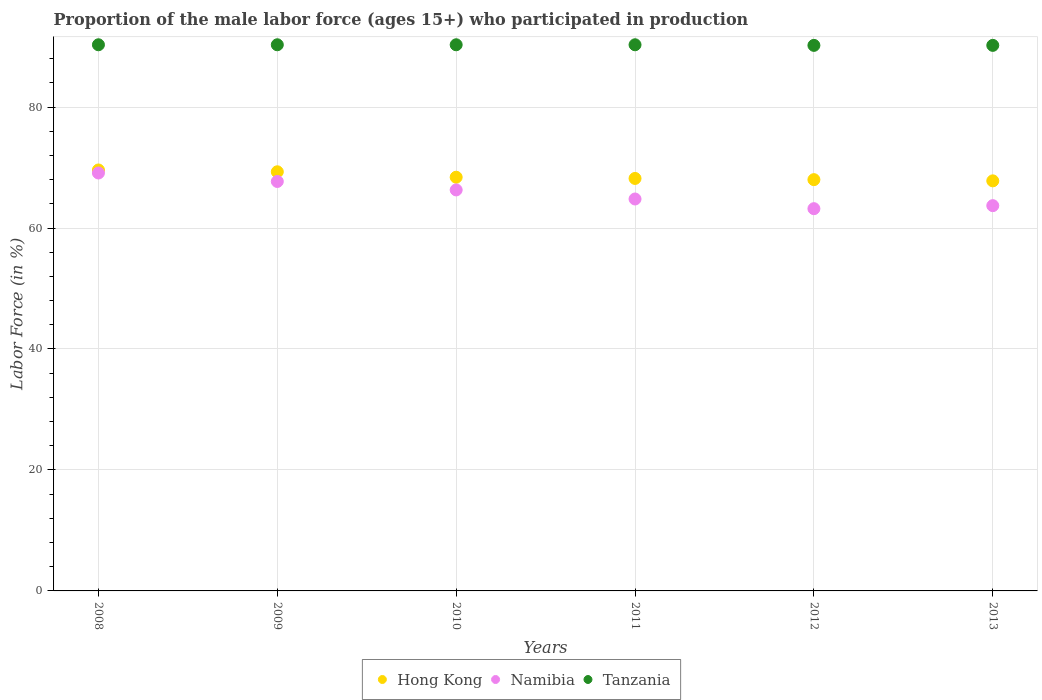How many different coloured dotlines are there?
Your response must be concise. 3. What is the proportion of the male labor force who participated in production in Namibia in 2008?
Make the answer very short. 69.1. Across all years, what is the maximum proportion of the male labor force who participated in production in Tanzania?
Give a very brief answer. 90.3. Across all years, what is the minimum proportion of the male labor force who participated in production in Namibia?
Provide a short and direct response. 63.2. In which year was the proportion of the male labor force who participated in production in Tanzania minimum?
Make the answer very short. 2012. What is the total proportion of the male labor force who participated in production in Tanzania in the graph?
Give a very brief answer. 541.6. What is the difference between the proportion of the male labor force who participated in production in Namibia in 2010 and that in 2012?
Provide a succinct answer. 3.1. What is the difference between the proportion of the male labor force who participated in production in Namibia in 2013 and the proportion of the male labor force who participated in production in Tanzania in 2010?
Your answer should be compact. -26.6. What is the average proportion of the male labor force who participated in production in Hong Kong per year?
Offer a very short reply. 68.55. In the year 2012, what is the difference between the proportion of the male labor force who participated in production in Namibia and proportion of the male labor force who participated in production in Hong Kong?
Offer a very short reply. -4.8. What is the ratio of the proportion of the male labor force who participated in production in Namibia in 2008 to that in 2009?
Keep it short and to the point. 1.02. Is the proportion of the male labor force who participated in production in Tanzania in 2011 less than that in 2012?
Your response must be concise. No. What is the difference between the highest and the second highest proportion of the male labor force who participated in production in Namibia?
Your answer should be compact. 1.4. What is the difference between the highest and the lowest proportion of the male labor force who participated in production in Hong Kong?
Your response must be concise. 1.8. Is the sum of the proportion of the male labor force who participated in production in Namibia in 2009 and 2012 greater than the maximum proportion of the male labor force who participated in production in Hong Kong across all years?
Make the answer very short. Yes. Does the proportion of the male labor force who participated in production in Namibia monotonically increase over the years?
Your response must be concise. No. Are the values on the major ticks of Y-axis written in scientific E-notation?
Your answer should be very brief. No. Does the graph contain grids?
Offer a terse response. Yes. Where does the legend appear in the graph?
Offer a very short reply. Bottom center. How many legend labels are there?
Provide a succinct answer. 3. What is the title of the graph?
Keep it short and to the point. Proportion of the male labor force (ages 15+) who participated in production. What is the label or title of the X-axis?
Your response must be concise. Years. What is the Labor Force (in %) of Hong Kong in 2008?
Offer a very short reply. 69.6. What is the Labor Force (in %) in Namibia in 2008?
Ensure brevity in your answer.  69.1. What is the Labor Force (in %) of Tanzania in 2008?
Your answer should be very brief. 90.3. What is the Labor Force (in %) of Hong Kong in 2009?
Make the answer very short. 69.3. What is the Labor Force (in %) of Namibia in 2009?
Your response must be concise. 67.7. What is the Labor Force (in %) in Tanzania in 2009?
Ensure brevity in your answer.  90.3. What is the Labor Force (in %) in Hong Kong in 2010?
Provide a short and direct response. 68.4. What is the Labor Force (in %) in Namibia in 2010?
Your answer should be very brief. 66.3. What is the Labor Force (in %) of Tanzania in 2010?
Offer a terse response. 90.3. What is the Labor Force (in %) in Hong Kong in 2011?
Keep it short and to the point. 68.2. What is the Labor Force (in %) of Namibia in 2011?
Ensure brevity in your answer.  64.8. What is the Labor Force (in %) of Tanzania in 2011?
Your answer should be compact. 90.3. What is the Labor Force (in %) of Hong Kong in 2012?
Make the answer very short. 68. What is the Labor Force (in %) of Namibia in 2012?
Make the answer very short. 63.2. What is the Labor Force (in %) of Tanzania in 2012?
Offer a very short reply. 90.2. What is the Labor Force (in %) of Hong Kong in 2013?
Provide a short and direct response. 67.8. What is the Labor Force (in %) of Namibia in 2013?
Provide a short and direct response. 63.7. What is the Labor Force (in %) in Tanzania in 2013?
Offer a very short reply. 90.2. Across all years, what is the maximum Labor Force (in %) in Hong Kong?
Offer a terse response. 69.6. Across all years, what is the maximum Labor Force (in %) of Namibia?
Ensure brevity in your answer.  69.1. Across all years, what is the maximum Labor Force (in %) in Tanzania?
Provide a short and direct response. 90.3. Across all years, what is the minimum Labor Force (in %) in Hong Kong?
Your response must be concise. 67.8. Across all years, what is the minimum Labor Force (in %) in Namibia?
Your answer should be very brief. 63.2. Across all years, what is the minimum Labor Force (in %) of Tanzania?
Provide a short and direct response. 90.2. What is the total Labor Force (in %) in Hong Kong in the graph?
Offer a very short reply. 411.3. What is the total Labor Force (in %) of Namibia in the graph?
Provide a short and direct response. 394.8. What is the total Labor Force (in %) in Tanzania in the graph?
Your answer should be very brief. 541.6. What is the difference between the Labor Force (in %) in Hong Kong in 2008 and that in 2009?
Your response must be concise. 0.3. What is the difference between the Labor Force (in %) of Namibia in 2008 and that in 2010?
Give a very brief answer. 2.8. What is the difference between the Labor Force (in %) of Hong Kong in 2008 and that in 2011?
Make the answer very short. 1.4. What is the difference between the Labor Force (in %) of Tanzania in 2008 and that in 2011?
Your answer should be compact. 0. What is the difference between the Labor Force (in %) in Namibia in 2008 and that in 2012?
Offer a very short reply. 5.9. What is the difference between the Labor Force (in %) of Hong Kong in 2008 and that in 2013?
Ensure brevity in your answer.  1.8. What is the difference between the Labor Force (in %) in Hong Kong in 2009 and that in 2010?
Offer a terse response. 0.9. What is the difference between the Labor Force (in %) of Tanzania in 2009 and that in 2010?
Your answer should be very brief. 0. What is the difference between the Labor Force (in %) of Hong Kong in 2009 and that in 2011?
Ensure brevity in your answer.  1.1. What is the difference between the Labor Force (in %) of Namibia in 2009 and that in 2011?
Offer a very short reply. 2.9. What is the difference between the Labor Force (in %) of Hong Kong in 2009 and that in 2012?
Give a very brief answer. 1.3. What is the difference between the Labor Force (in %) in Tanzania in 2009 and that in 2012?
Provide a short and direct response. 0.1. What is the difference between the Labor Force (in %) in Hong Kong in 2009 and that in 2013?
Make the answer very short. 1.5. What is the difference between the Labor Force (in %) of Namibia in 2009 and that in 2013?
Your response must be concise. 4. What is the difference between the Labor Force (in %) in Tanzania in 2009 and that in 2013?
Provide a succinct answer. 0.1. What is the difference between the Labor Force (in %) of Hong Kong in 2010 and that in 2011?
Offer a very short reply. 0.2. What is the difference between the Labor Force (in %) of Hong Kong in 2010 and that in 2012?
Give a very brief answer. 0.4. What is the difference between the Labor Force (in %) of Namibia in 2010 and that in 2012?
Your answer should be very brief. 3.1. What is the difference between the Labor Force (in %) in Namibia in 2011 and that in 2012?
Make the answer very short. 1.6. What is the difference between the Labor Force (in %) of Namibia in 2011 and that in 2013?
Give a very brief answer. 1.1. What is the difference between the Labor Force (in %) in Hong Kong in 2012 and that in 2013?
Make the answer very short. 0.2. What is the difference between the Labor Force (in %) in Tanzania in 2012 and that in 2013?
Make the answer very short. 0. What is the difference between the Labor Force (in %) of Hong Kong in 2008 and the Labor Force (in %) of Tanzania in 2009?
Your answer should be compact. -20.7. What is the difference between the Labor Force (in %) in Namibia in 2008 and the Labor Force (in %) in Tanzania in 2009?
Offer a very short reply. -21.2. What is the difference between the Labor Force (in %) of Hong Kong in 2008 and the Labor Force (in %) of Namibia in 2010?
Give a very brief answer. 3.3. What is the difference between the Labor Force (in %) of Hong Kong in 2008 and the Labor Force (in %) of Tanzania in 2010?
Offer a very short reply. -20.7. What is the difference between the Labor Force (in %) in Namibia in 2008 and the Labor Force (in %) in Tanzania in 2010?
Give a very brief answer. -21.2. What is the difference between the Labor Force (in %) of Hong Kong in 2008 and the Labor Force (in %) of Tanzania in 2011?
Give a very brief answer. -20.7. What is the difference between the Labor Force (in %) of Namibia in 2008 and the Labor Force (in %) of Tanzania in 2011?
Your response must be concise. -21.2. What is the difference between the Labor Force (in %) of Hong Kong in 2008 and the Labor Force (in %) of Tanzania in 2012?
Your answer should be very brief. -20.6. What is the difference between the Labor Force (in %) in Namibia in 2008 and the Labor Force (in %) in Tanzania in 2012?
Give a very brief answer. -21.1. What is the difference between the Labor Force (in %) of Hong Kong in 2008 and the Labor Force (in %) of Namibia in 2013?
Your response must be concise. 5.9. What is the difference between the Labor Force (in %) in Hong Kong in 2008 and the Labor Force (in %) in Tanzania in 2013?
Provide a short and direct response. -20.6. What is the difference between the Labor Force (in %) of Namibia in 2008 and the Labor Force (in %) of Tanzania in 2013?
Keep it short and to the point. -21.1. What is the difference between the Labor Force (in %) in Hong Kong in 2009 and the Labor Force (in %) in Namibia in 2010?
Give a very brief answer. 3. What is the difference between the Labor Force (in %) of Namibia in 2009 and the Labor Force (in %) of Tanzania in 2010?
Your response must be concise. -22.6. What is the difference between the Labor Force (in %) in Namibia in 2009 and the Labor Force (in %) in Tanzania in 2011?
Offer a very short reply. -22.6. What is the difference between the Labor Force (in %) in Hong Kong in 2009 and the Labor Force (in %) in Namibia in 2012?
Provide a short and direct response. 6.1. What is the difference between the Labor Force (in %) of Hong Kong in 2009 and the Labor Force (in %) of Tanzania in 2012?
Give a very brief answer. -20.9. What is the difference between the Labor Force (in %) in Namibia in 2009 and the Labor Force (in %) in Tanzania in 2012?
Provide a succinct answer. -22.5. What is the difference between the Labor Force (in %) of Hong Kong in 2009 and the Labor Force (in %) of Namibia in 2013?
Provide a succinct answer. 5.6. What is the difference between the Labor Force (in %) of Hong Kong in 2009 and the Labor Force (in %) of Tanzania in 2013?
Provide a succinct answer. -20.9. What is the difference between the Labor Force (in %) in Namibia in 2009 and the Labor Force (in %) in Tanzania in 2013?
Keep it short and to the point. -22.5. What is the difference between the Labor Force (in %) of Hong Kong in 2010 and the Labor Force (in %) of Tanzania in 2011?
Offer a very short reply. -21.9. What is the difference between the Labor Force (in %) in Namibia in 2010 and the Labor Force (in %) in Tanzania in 2011?
Provide a succinct answer. -24. What is the difference between the Labor Force (in %) in Hong Kong in 2010 and the Labor Force (in %) in Namibia in 2012?
Your answer should be very brief. 5.2. What is the difference between the Labor Force (in %) in Hong Kong in 2010 and the Labor Force (in %) in Tanzania in 2012?
Make the answer very short. -21.8. What is the difference between the Labor Force (in %) of Namibia in 2010 and the Labor Force (in %) of Tanzania in 2012?
Offer a terse response. -23.9. What is the difference between the Labor Force (in %) in Hong Kong in 2010 and the Labor Force (in %) in Namibia in 2013?
Make the answer very short. 4.7. What is the difference between the Labor Force (in %) of Hong Kong in 2010 and the Labor Force (in %) of Tanzania in 2013?
Keep it short and to the point. -21.8. What is the difference between the Labor Force (in %) of Namibia in 2010 and the Labor Force (in %) of Tanzania in 2013?
Provide a short and direct response. -23.9. What is the difference between the Labor Force (in %) in Namibia in 2011 and the Labor Force (in %) in Tanzania in 2012?
Ensure brevity in your answer.  -25.4. What is the difference between the Labor Force (in %) in Namibia in 2011 and the Labor Force (in %) in Tanzania in 2013?
Provide a short and direct response. -25.4. What is the difference between the Labor Force (in %) of Hong Kong in 2012 and the Labor Force (in %) of Namibia in 2013?
Your response must be concise. 4.3. What is the difference between the Labor Force (in %) in Hong Kong in 2012 and the Labor Force (in %) in Tanzania in 2013?
Make the answer very short. -22.2. What is the difference between the Labor Force (in %) of Namibia in 2012 and the Labor Force (in %) of Tanzania in 2013?
Give a very brief answer. -27. What is the average Labor Force (in %) in Hong Kong per year?
Provide a succinct answer. 68.55. What is the average Labor Force (in %) of Namibia per year?
Keep it short and to the point. 65.8. What is the average Labor Force (in %) of Tanzania per year?
Your response must be concise. 90.27. In the year 2008, what is the difference between the Labor Force (in %) of Hong Kong and Labor Force (in %) of Tanzania?
Provide a short and direct response. -20.7. In the year 2008, what is the difference between the Labor Force (in %) of Namibia and Labor Force (in %) of Tanzania?
Provide a short and direct response. -21.2. In the year 2009, what is the difference between the Labor Force (in %) in Namibia and Labor Force (in %) in Tanzania?
Your response must be concise. -22.6. In the year 2010, what is the difference between the Labor Force (in %) in Hong Kong and Labor Force (in %) in Namibia?
Your answer should be compact. 2.1. In the year 2010, what is the difference between the Labor Force (in %) in Hong Kong and Labor Force (in %) in Tanzania?
Your answer should be compact. -21.9. In the year 2011, what is the difference between the Labor Force (in %) in Hong Kong and Labor Force (in %) in Tanzania?
Your answer should be very brief. -22.1. In the year 2011, what is the difference between the Labor Force (in %) of Namibia and Labor Force (in %) of Tanzania?
Make the answer very short. -25.5. In the year 2012, what is the difference between the Labor Force (in %) in Hong Kong and Labor Force (in %) in Tanzania?
Provide a succinct answer. -22.2. In the year 2012, what is the difference between the Labor Force (in %) in Namibia and Labor Force (in %) in Tanzania?
Ensure brevity in your answer.  -27. In the year 2013, what is the difference between the Labor Force (in %) of Hong Kong and Labor Force (in %) of Tanzania?
Make the answer very short. -22.4. In the year 2013, what is the difference between the Labor Force (in %) of Namibia and Labor Force (in %) of Tanzania?
Your answer should be very brief. -26.5. What is the ratio of the Labor Force (in %) of Namibia in 2008 to that in 2009?
Keep it short and to the point. 1.02. What is the ratio of the Labor Force (in %) of Hong Kong in 2008 to that in 2010?
Provide a short and direct response. 1.02. What is the ratio of the Labor Force (in %) of Namibia in 2008 to that in 2010?
Provide a succinct answer. 1.04. What is the ratio of the Labor Force (in %) in Hong Kong in 2008 to that in 2011?
Make the answer very short. 1.02. What is the ratio of the Labor Force (in %) of Namibia in 2008 to that in 2011?
Your answer should be very brief. 1.07. What is the ratio of the Labor Force (in %) of Tanzania in 2008 to that in 2011?
Provide a short and direct response. 1. What is the ratio of the Labor Force (in %) of Hong Kong in 2008 to that in 2012?
Your answer should be very brief. 1.02. What is the ratio of the Labor Force (in %) in Namibia in 2008 to that in 2012?
Offer a very short reply. 1.09. What is the ratio of the Labor Force (in %) in Tanzania in 2008 to that in 2012?
Keep it short and to the point. 1. What is the ratio of the Labor Force (in %) of Hong Kong in 2008 to that in 2013?
Keep it short and to the point. 1.03. What is the ratio of the Labor Force (in %) of Namibia in 2008 to that in 2013?
Offer a terse response. 1.08. What is the ratio of the Labor Force (in %) of Tanzania in 2008 to that in 2013?
Provide a succinct answer. 1. What is the ratio of the Labor Force (in %) of Hong Kong in 2009 to that in 2010?
Offer a terse response. 1.01. What is the ratio of the Labor Force (in %) in Namibia in 2009 to that in 2010?
Ensure brevity in your answer.  1.02. What is the ratio of the Labor Force (in %) in Tanzania in 2009 to that in 2010?
Offer a very short reply. 1. What is the ratio of the Labor Force (in %) of Hong Kong in 2009 to that in 2011?
Your answer should be very brief. 1.02. What is the ratio of the Labor Force (in %) in Namibia in 2009 to that in 2011?
Offer a terse response. 1.04. What is the ratio of the Labor Force (in %) of Hong Kong in 2009 to that in 2012?
Ensure brevity in your answer.  1.02. What is the ratio of the Labor Force (in %) of Namibia in 2009 to that in 2012?
Keep it short and to the point. 1.07. What is the ratio of the Labor Force (in %) of Tanzania in 2009 to that in 2012?
Provide a succinct answer. 1. What is the ratio of the Labor Force (in %) of Hong Kong in 2009 to that in 2013?
Your answer should be compact. 1.02. What is the ratio of the Labor Force (in %) in Namibia in 2009 to that in 2013?
Offer a very short reply. 1.06. What is the ratio of the Labor Force (in %) of Hong Kong in 2010 to that in 2011?
Offer a very short reply. 1. What is the ratio of the Labor Force (in %) in Namibia in 2010 to that in 2011?
Offer a terse response. 1.02. What is the ratio of the Labor Force (in %) in Hong Kong in 2010 to that in 2012?
Provide a short and direct response. 1.01. What is the ratio of the Labor Force (in %) in Namibia in 2010 to that in 2012?
Give a very brief answer. 1.05. What is the ratio of the Labor Force (in %) in Hong Kong in 2010 to that in 2013?
Offer a terse response. 1.01. What is the ratio of the Labor Force (in %) of Namibia in 2010 to that in 2013?
Make the answer very short. 1.04. What is the ratio of the Labor Force (in %) of Namibia in 2011 to that in 2012?
Make the answer very short. 1.03. What is the ratio of the Labor Force (in %) in Hong Kong in 2011 to that in 2013?
Offer a terse response. 1.01. What is the ratio of the Labor Force (in %) of Namibia in 2011 to that in 2013?
Offer a very short reply. 1.02. What is the ratio of the Labor Force (in %) in Hong Kong in 2012 to that in 2013?
Provide a short and direct response. 1. What is the ratio of the Labor Force (in %) in Namibia in 2012 to that in 2013?
Offer a terse response. 0.99. What is the ratio of the Labor Force (in %) in Tanzania in 2012 to that in 2013?
Your answer should be very brief. 1. What is the difference between the highest and the second highest Labor Force (in %) of Namibia?
Your response must be concise. 1.4. What is the difference between the highest and the lowest Labor Force (in %) in Hong Kong?
Provide a succinct answer. 1.8. What is the difference between the highest and the lowest Labor Force (in %) in Namibia?
Provide a short and direct response. 5.9. 